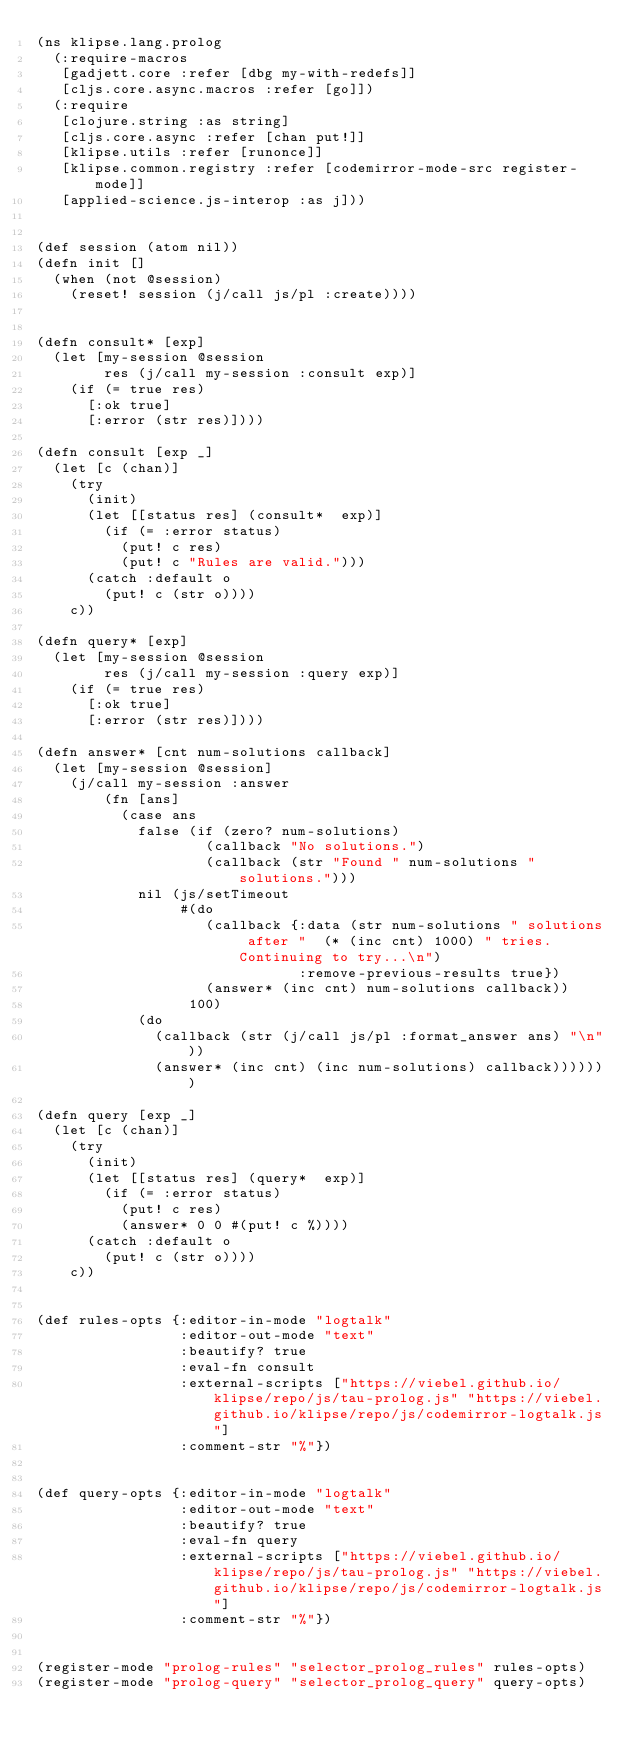Convert code to text. <code><loc_0><loc_0><loc_500><loc_500><_Clojure_>(ns klipse.lang.prolog
  (:require-macros
   [gadjett.core :refer [dbg my-with-redefs]]
   [cljs.core.async.macros :refer [go]])
  (:require
   [clojure.string :as string]
   [cljs.core.async :refer [chan put!]]
   [klipse.utils :refer [runonce]]
   [klipse.common.registry :refer [codemirror-mode-src register-mode]]
   [applied-science.js-interop :as j]))


(def session (atom nil))
(defn init []
  (when (not @session)
    (reset! session (j/call js/pl :create))))


(defn consult* [exp]
  (let [my-session @session
        res (j/call my-session :consult exp)]
    (if (= true res)
      [:ok true]
      [:error (str res)])))

(defn consult [exp _]
  (let [c (chan)]
    (try
      (init)
      (let [[status res] (consult*  exp)]
        (if (= :error status)
          (put! c res)
          (put! c "Rules are valid.")))
      (catch :default o
        (put! c (str o))))
    c))

(defn query* [exp]
  (let [my-session @session
        res (j/call my-session :query exp)]
    (if (= true res)
      [:ok true]
      [:error (str res)])))

(defn answer* [cnt num-solutions callback]
  (let [my-session @session]
    (j/call my-session :answer
        (fn [ans]
          (case ans
            false (if (zero? num-solutions)
                    (callback "No solutions.")
                    (callback (str "Found " num-solutions " solutions.")))
            nil (js/setTimeout
                 #(do
                    (callback {:data (str num-solutions " solutions after "  (* (inc cnt) 1000) " tries. Continuing to try...\n")
                               :remove-previous-results true})
                    (answer* (inc cnt) num-solutions callback))
                  100)
            (do
              (callback (str (j/call js/pl :format_answer ans) "\n"))
              (answer* (inc cnt) (inc num-solutions) callback)))))))

(defn query [exp _]
  (let [c (chan)]
    (try
      (init)
      (let [[status res] (query*  exp)]
        (if (= :error status)
          (put! c res)
          (answer* 0 0 #(put! c %))))
      (catch :default o
        (put! c (str o))))
    c))


(def rules-opts {:editor-in-mode "logtalk"
                 :editor-out-mode "text"
                 :beautify? true
                 :eval-fn consult
                 :external-scripts ["https://viebel.github.io/klipse/repo/js/tau-prolog.js" "https://viebel.github.io/klipse/repo/js/codemirror-logtalk.js"]
                 :comment-str "%"})


(def query-opts {:editor-in-mode "logtalk"
                 :editor-out-mode "text"
                 :beautify? true
                 :eval-fn query
                 :external-scripts ["https://viebel.github.io/klipse/repo/js/tau-prolog.js" "https://viebel.github.io/klipse/repo/js/codemirror-logtalk.js"]
                 :comment-str "%"})


(register-mode "prolog-rules" "selector_prolog_rules" rules-opts)
(register-mode "prolog-query" "selector_prolog_query" query-opts)

</code> 